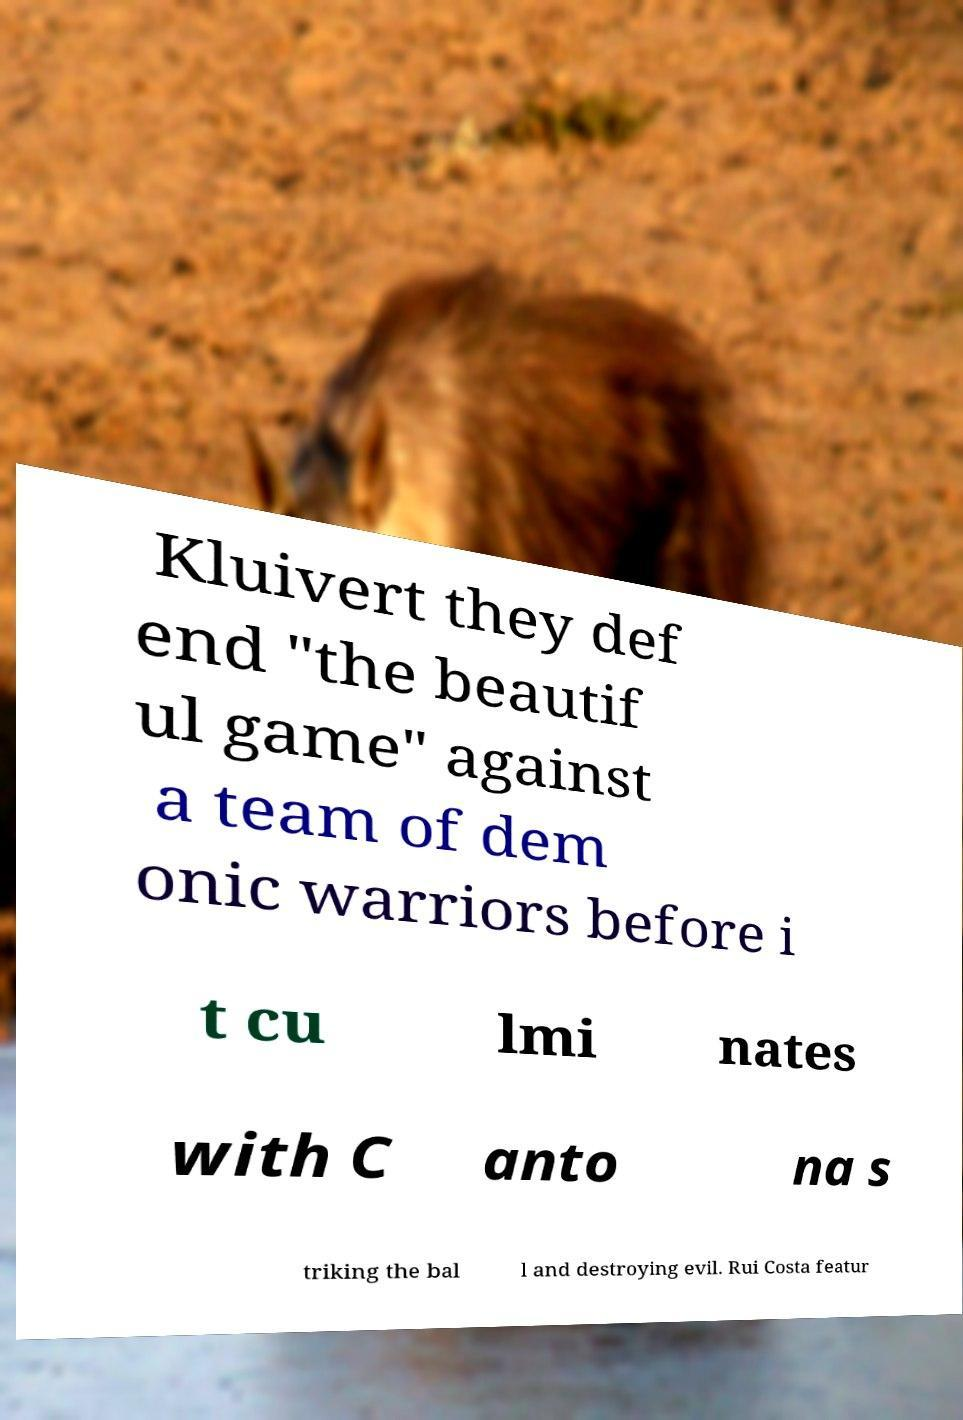Please read and relay the text visible in this image. What does it say? Kluivert they def end "the beautif ul game" against a team of dem onic warriors before i t cu lmi nates with C anto na s triking the bal l and destroying evil. Rui Costa featur 